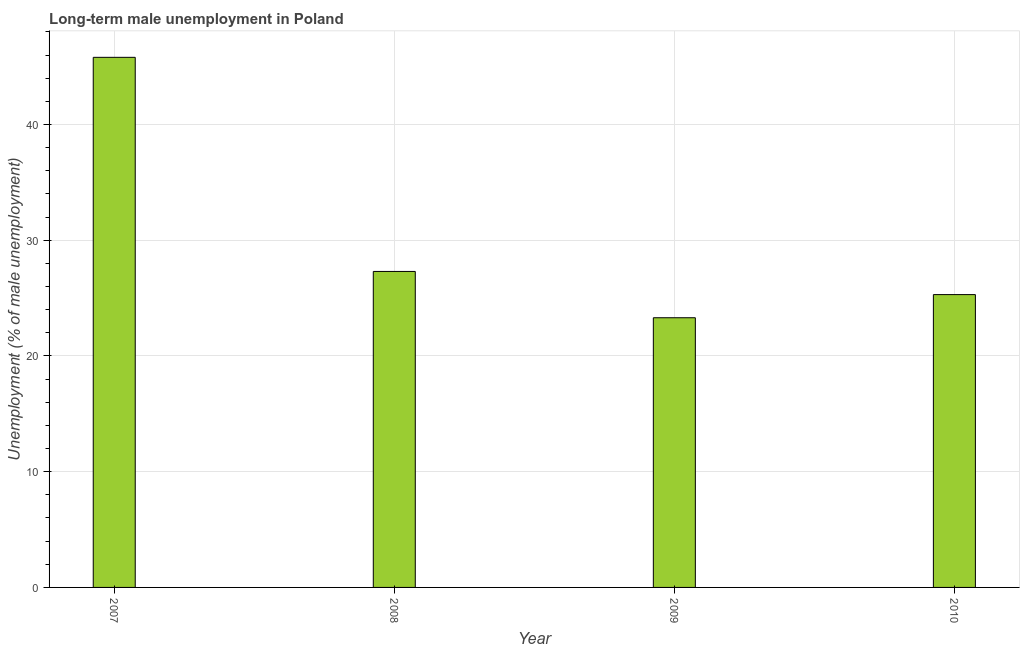Does the graph contain grids?
Provide a succinct answer. Yes. What is the title of the graph?
Your answer should be very brief. Long-term male unemployment in Poland. What is the label or title of the Y-axis?
Make the answer very short. Unemployment (% of male unemployment). What is the long-term male unemployment in 2009?
Your answer should be compact. 23.3. Across all years, what is the maximum long-term male unemployment?
Your response must be concise. 45.8. Across all years, what is the minimum long-term male unemployment?
Ensure brevity in your answer.  23.3. In which year was the long-term male unemployment maximum?
Give a very brief answer. 2007. In which year was the long-term male unemployment minimum?
Keep it short and to the point. 2009. What is the sum of the long-term male unemployment?
Make the answer very short. 121.7. What is the average long-term male unemployment per year?
Give a very brief answer. 30.43. What is the median long-term male unemployment?
Provide a short and direct response. 26.3. Do a majority of the years between 2009 and 2007 (inclusive) have long-term male unemployment greater than 8 %?
Your answer should be compact. Yes. What is the ratio of the long-term male unemployment in 2007 to that in 2010?
Offer a terse response. 1.81. Is the long-term male unemployment in 2008 less than that in 2010?
Make the answer very short. No. What is the difference between the highest and the second highest long-term male unemployment?
Ensure brevity in your answer.  18.5. Is the sum of the long-term male unemployment in 2007 and 2010 greater than the maximum long-term male unemployment across all years?
Provide a succinct answer. Yes. In how many years, is the long-term male unemployment greater than the average long-term male unemployment taken over all years?
Your response must be concise. 1. How many bars are there?
Your answer should be compact. 4. Are all the bars in the graph horizontal?
Your answer should be compact. No. How many years are there in the graph?
Give a very brief answer. 4. What is the difference between two consecutive major ticks on the Y-axis?
Offer a terse response. 10. What is the Unemployment (% of male unemployment) of 2007?
Your response must be concise. 45.8. What is the Unemployment (% of male unemployment) of 2008?
Offer a very short reply. 27.3. What is the Unemployment (% of male unemployment) in 2009?
Provide a short and direct response. 23.3. What is the Unemployment (% of male unemployment) of 2010?
Keep it short and to the point. 25.3. What is the difference between the Unemployment (% of male unemployment) in 2007 and 2008?
Your response must be concise. 18.5. What is the ratio of the Unemployment (% of male unemployment) in 2007 to that in 2008?
Your answer should be compact. 1.68. What is the ratio of the Unemployment (% of male unemployment) in 2007 to that in 2009?
Offer a very short reply. 1.97. What is the ratio of the Unemployment (% of male unemployment) in 2007 to that in 2010?
Keep it short and to the point. 1.81. What is the ratio of the Unemployment (% of male unemployment) in 2008 to that in 2009?
Give a very brief answer. 1.17. What is the ratio of the Unemployment (% of male unemployment) in 2008 to that in 2010?
Make the answer very short. 1.08. What is the ratio of the Unemployment (% of male unemployment) in 2009 to that in 2010?
Your response must be concise. 0.92. 